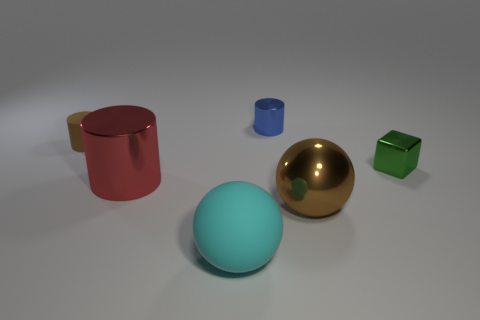Are there any other things that are the same shape as the green metallic object?
Your response must be concise. No. What is the material of the tiny brown object that is the same shape as the large red thing?
Your answer should be compact. Rubber. There is a rubber thing that is in front of the green object; does it have the same shape as the brown object that is on the left side of the cyan sphere?
Ensure brevity in your answer.  No. Are there fewer small rubber cylinders that are to the left of the small rubber object than metallic cylinders behind the shiny sphere?
Offer a terse response. Yes. How many other things are the same shape as the large brown thing?
Provide a succinct answer. 1. What shape is the large brown thing that is the same material as the blue object?
Ensure brevity in your answer.  Sphere. There is a big object that is behind the large cyan object and in front of the large red object; what color is it?
Provide a short and direct response. Brown. Is the material of the cylinder in front of the green object the same as the blue thing?
Provide a succinct answer. Yes. Is the number of green cubes that are behind the small blue metal object less than the number of big yellow metallic things?
Provide a succinct answer. No. Are there any brown cylinders made of the same material as the blue cylinder?
Your response must be concise. No. 